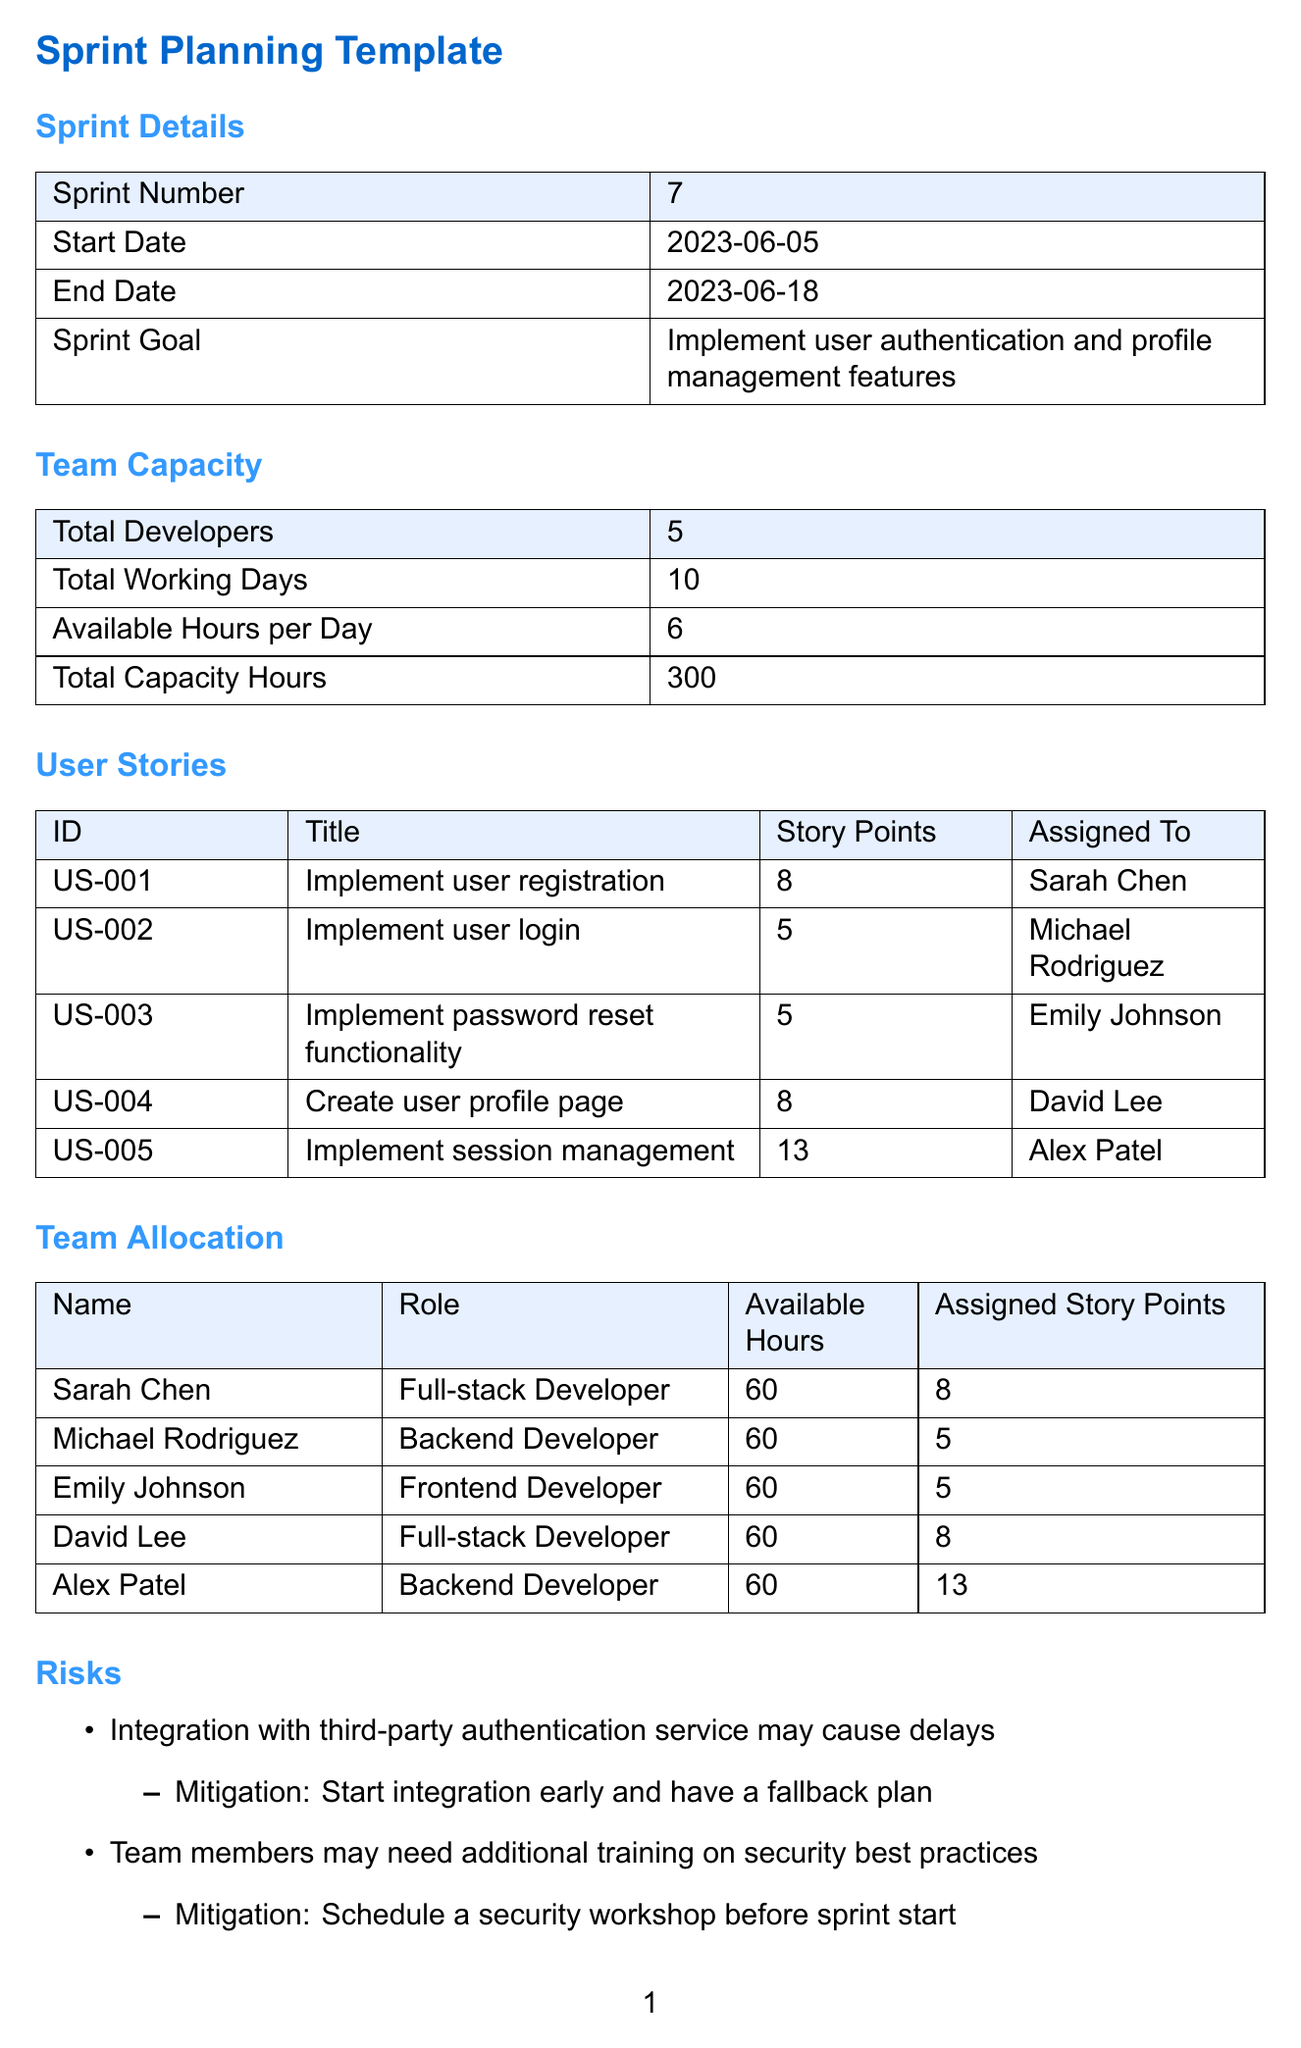What is the sprint number? The sprint number is stated in the document under sprint details.
Answer: 7 What is the total capacity hours available for the sprint? Total capacity hours are mentioned in the team capacity section.
Answer: 300 Who is assigned to implement user registration? The assigned developer for user registration is specified in the user stories section.
Answer: Sarah Chen What is the story point value for creating a user profile page? The document lists the story points for each user story, including the user profile page.
Answer: 8 What is the maximum available hours per day for the team? The maximum available hours per day are detailed in the team capacity section.
Answer: 6 Which user story must be completed before user login? The dependency section states the order of user stories that must be fulfilled.
Answer: User registration How many total developers are on the team? The total number of developers is provided in the team capacity section.
Answer: 5 What mitigation is suggested for potential delays caused by third-party authentication? The document suggests a specific mitigation strategy in the risks section.
Answer: Start integration early and have a fallback plan What role does Michael Rodriguez have in the project? The role of each team member is listed in the team allocation section.
Answer: Backend Developer 